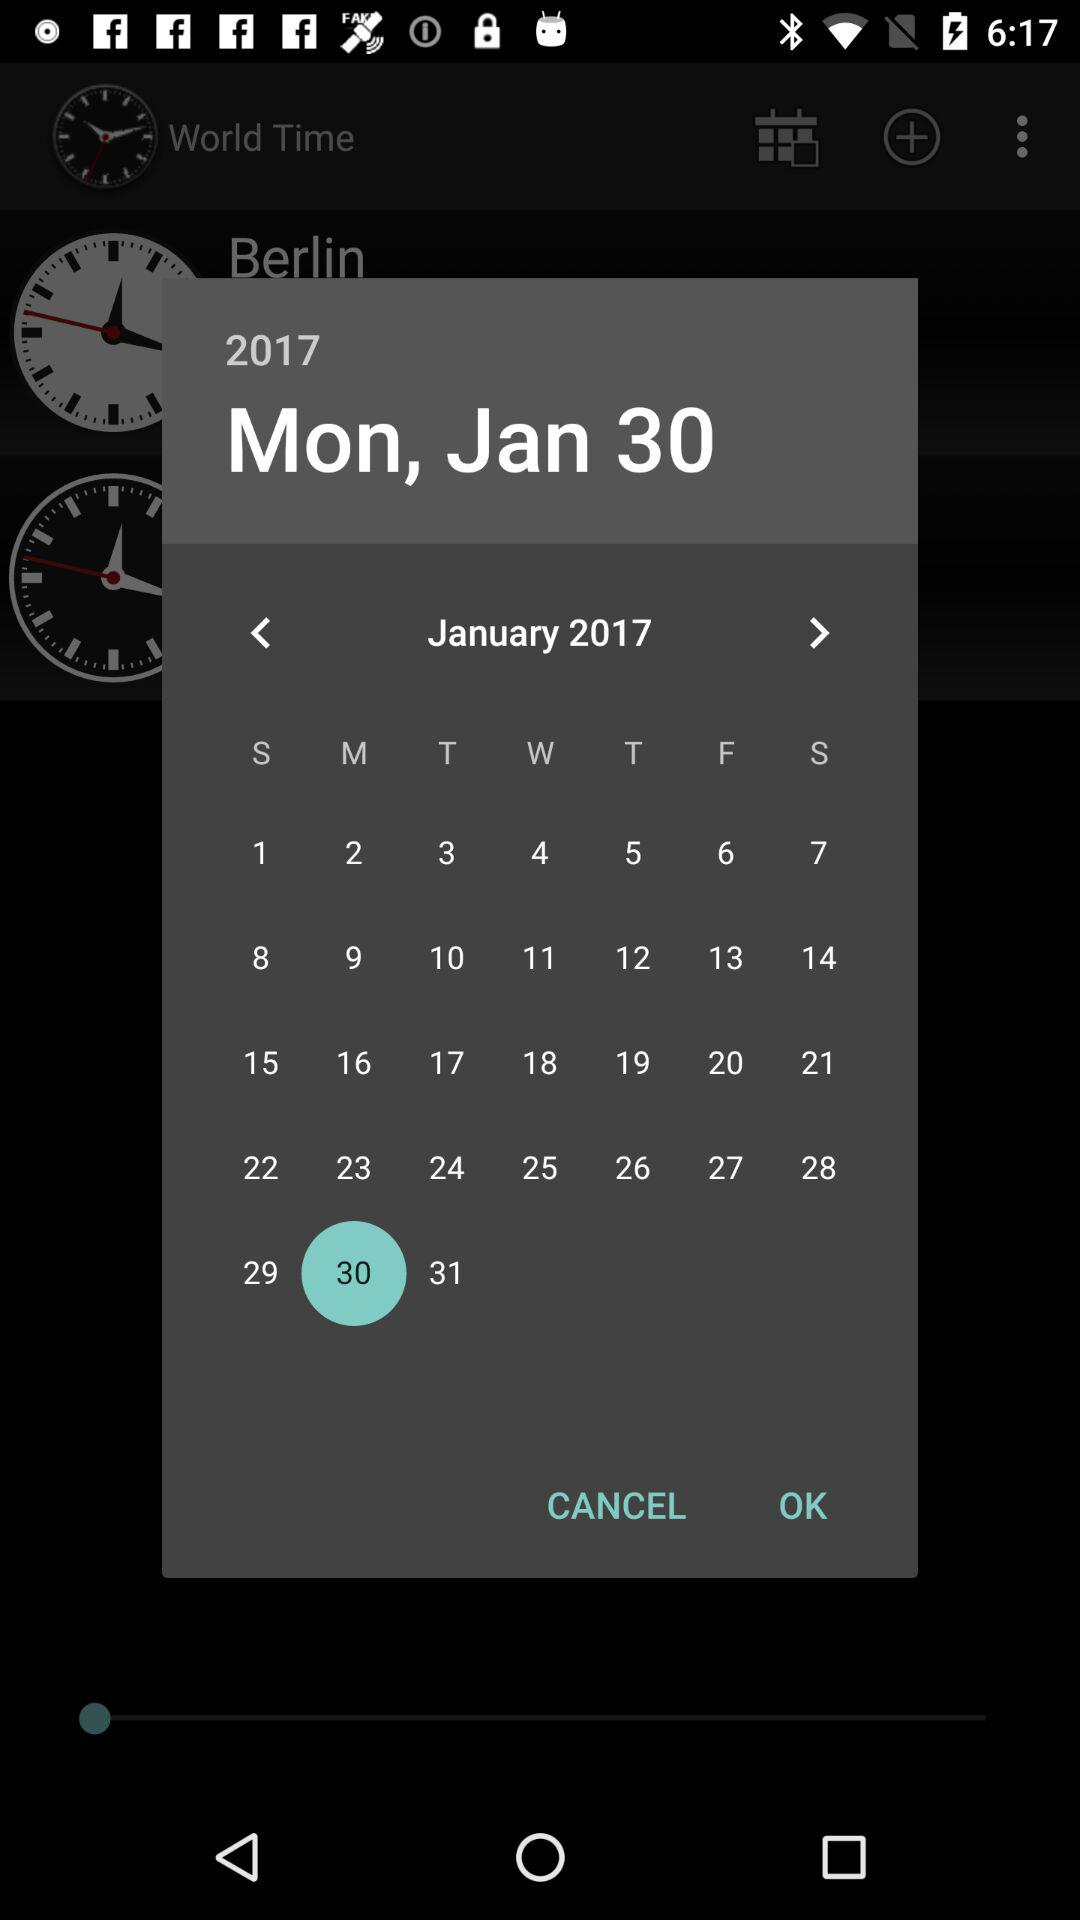What is the selected date? The selected date is Monday, January 30, 2017. 